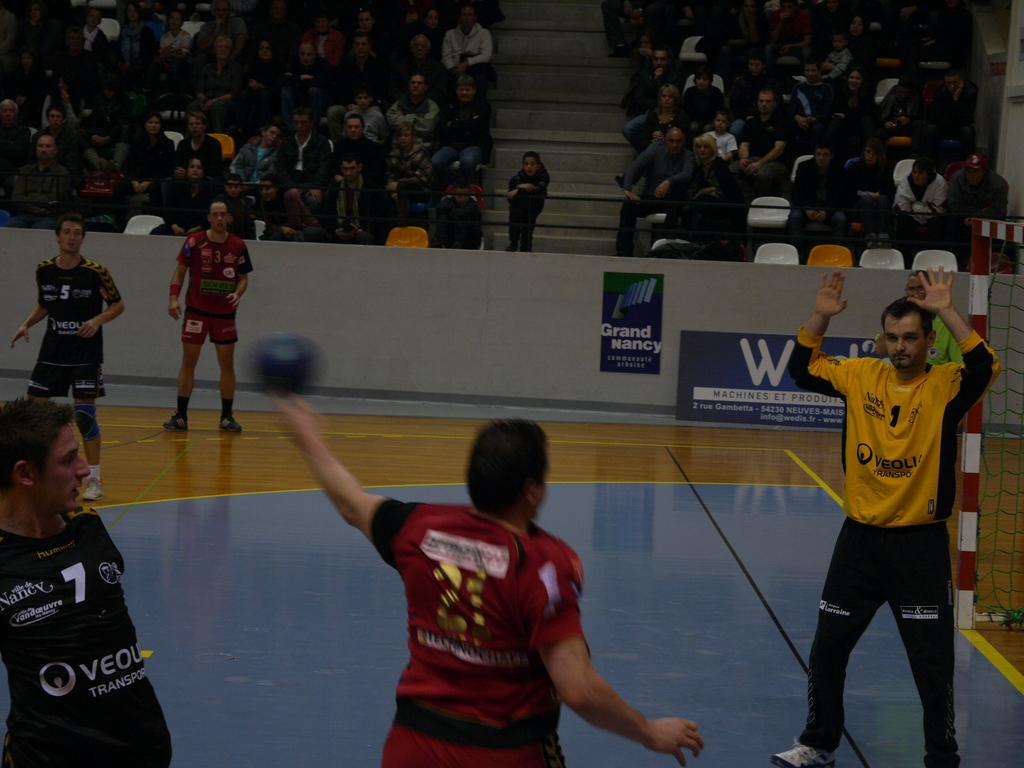What player number is the guy in yellow shirt?
Provide a short and direct response. 1. Who is a sponsor of this team?
Keep it short and to the point. Veoli. 